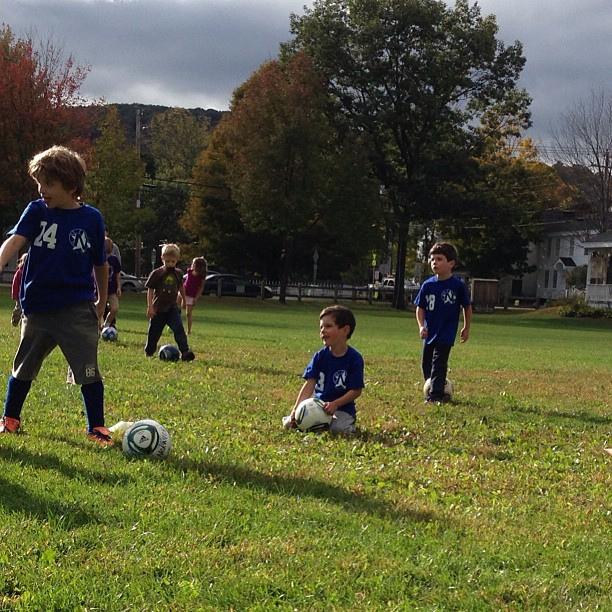Is this a professional sport?
Short answer required. No. How many people are shown?
Keep it brief. 7. Are these adults?
Short answer required. No. Where are the men playing at?
Write a very short answer. Field. Are the boys practicing or playing a game?
Quick response, please. Practicing. Are these people playing soccer?
Keep it brief. Yes. Are they playing soccer?
Keep it brief. Yes. What is color(s) of the ball?
Keep it brief. White and blue. 